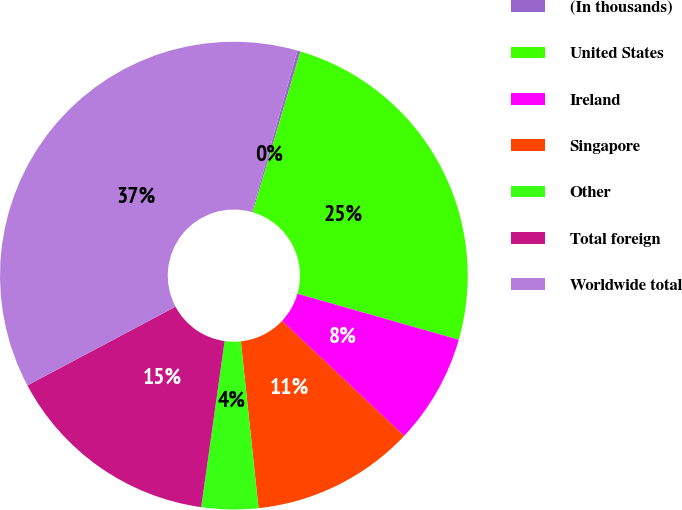<chart> <loc_0><loc_0><loc_500><loc_500><pie_chart><fcel>(In thousands)<fcel>United States<fcel>Ireland<fcel>Singapore<fcel>Other<fcel>Total foreign<fcel>Worldwide total<nl><fcel>0.21%<fcel>24.83%<fcel>7.6%<fcel>11.3%<fcel>3.91%<fcel>14.99%<fcel>37.16%<nl></chart> 